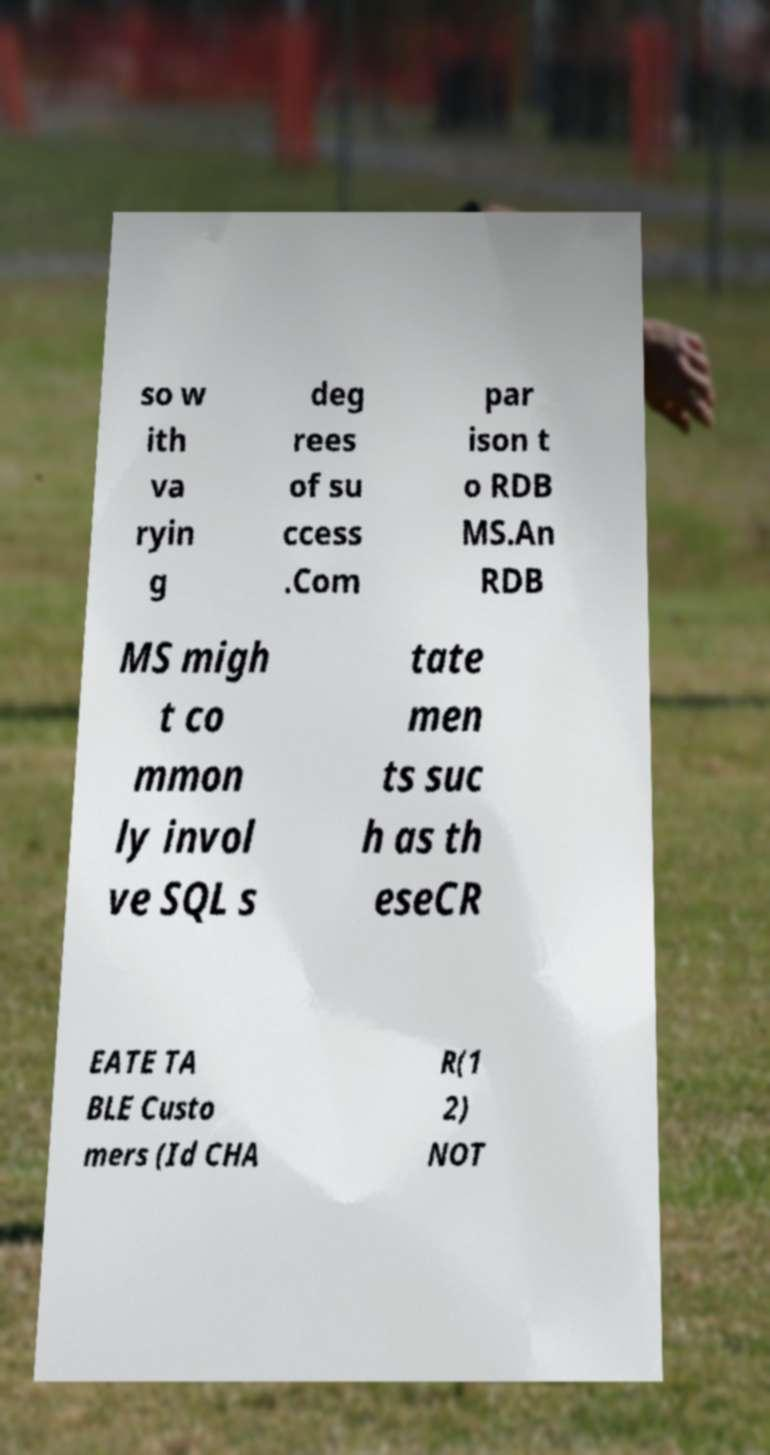Can you read and provide the text displayed in the image?This photo seems to have some interesting text. Can you extract and type it out for me? so w ith va ryin g deg rees of su ccess .Com par ison t o RDB MS.An RDB MS migh t co mmon ly invol ve SQL s tate men ts suc h as th eseCR EATE TA BLE Custo mers (Id CHA R(1 2) NOT 